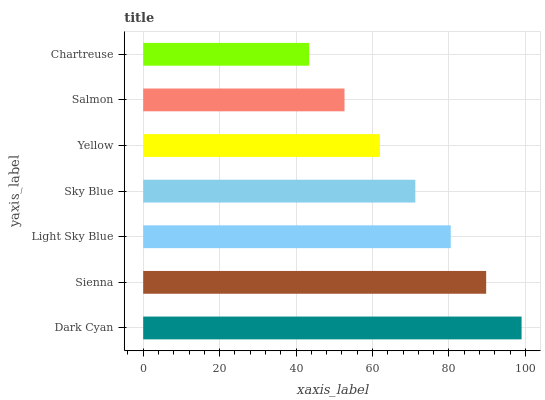Is Chartreuse the minimum?
Answer yes or no. Yes. Is Dark Cyan the maximum?
Answer yes or no. Yes. Is Sienna the minimum?
Answer yes or no. No. Is Sienna the maximum?
Answer yes or no. No. Is Dark Cyan greater than Sienna?
Answer yes or no. Yes. Is Sienna less than Dark Cyan?
Answer yes or no. Yes. Is Sienna greater than Dark Cyan?
Answer yes or no. No. Is Dark Cyan less than Sienna?
Answer yes or no. No. Is Sky Blue the high median?
Answer yes or no. Yes. Is Sky Blue the low median?
Answer yes or no. Yes. Is Sienna the high median?
Answer yes or no. No. Is Chartreuse the low median?
Answer yes or no. No. 